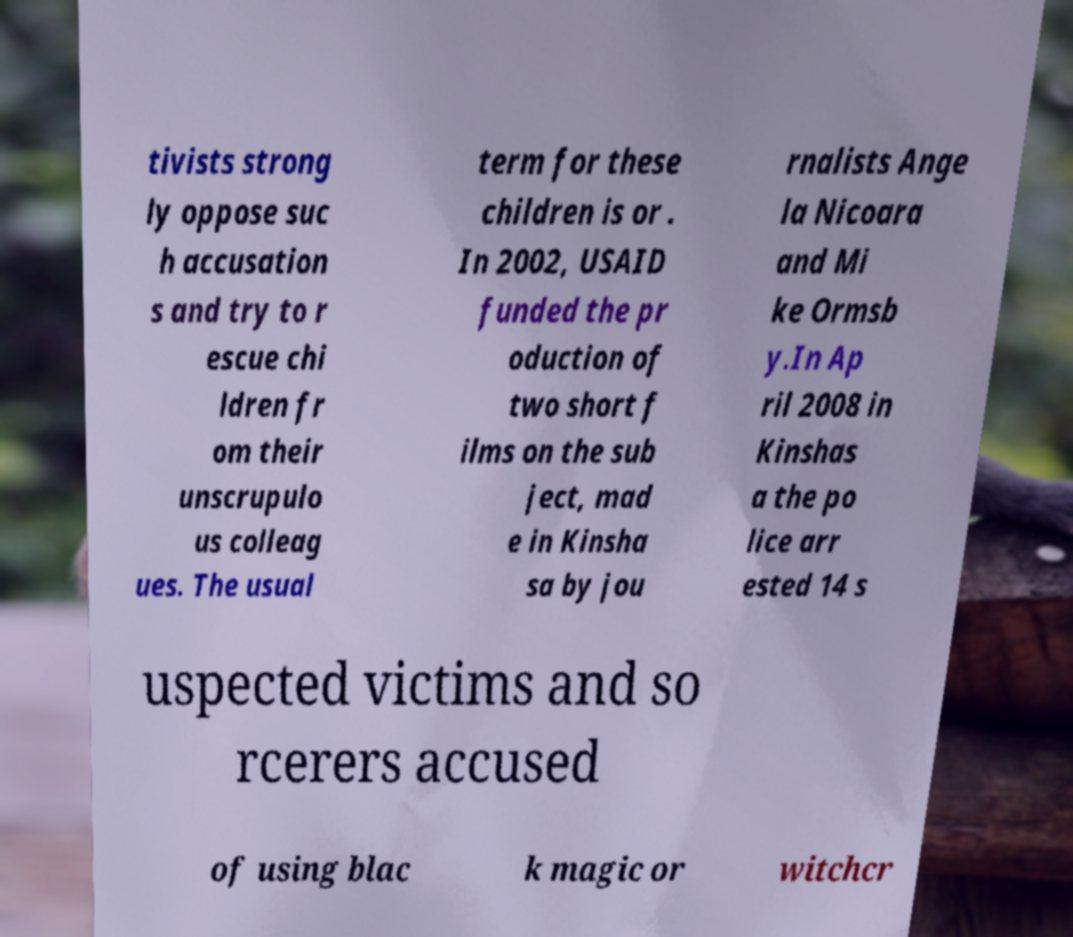Can you read and provide the text displayed in the image?This photo seems to have some interesting text. Can you extract and type it out for me? tivists strong ly oppose suc h accusation s and try to r escue chi ldren fr om their unscrupulo us colleag ues. The usual term for these children is or . In 2002, USAID funded the pr oduction of two short f ilms on the sub ject, mad e in Kinsha sa by jou rnalists Ange la Nicoara and Mi ke Ormsb y.In Ap ril 2008 in Kinshas a the po lice arr ested 14 s uspected victims and so rcerers accused of using blac k magic or witchcr 